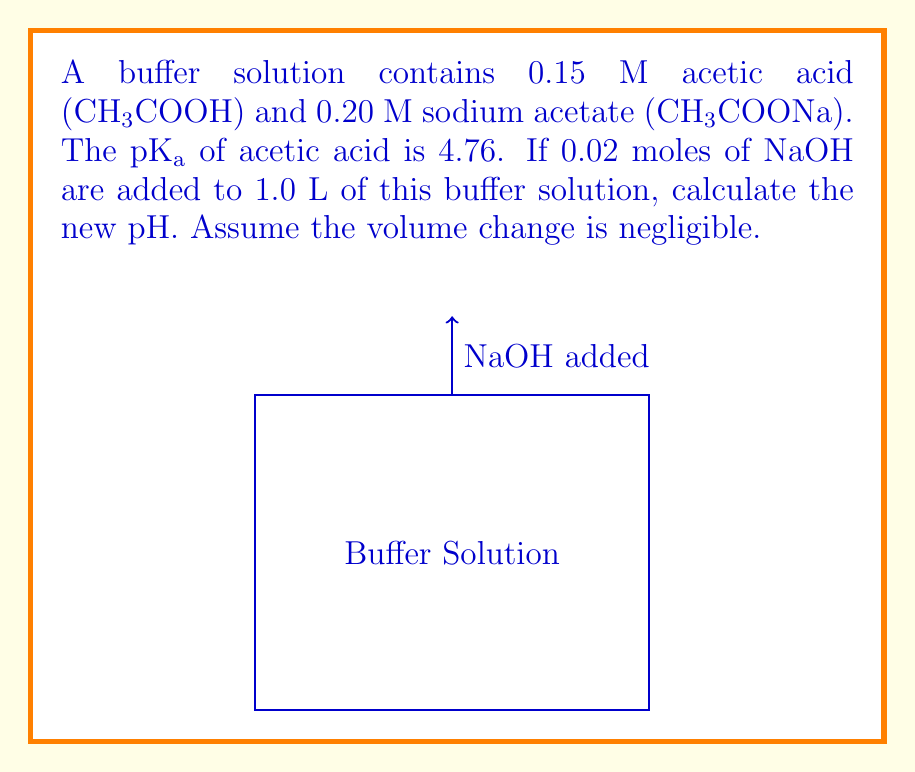Could you help me with this problem? Let's approach this step-by-step:

1) First, let's write the Henderson-Hasselbalch equation:
   $$ pH = pKa + \log\frac{[A^-]}{[HA]} $$

2) Initially, [HA] = 0.15 M and [A⁻] = 0.20 M
   $$ pH_{initial} = 4.76 + \log\frac{0.20}{0.15} = 4.76 + 0.12 = 4.88 $$

3) When NaOH is added, it reacts with HA:
   CH₃COOH + NaOH → CH₃COONa + H₂O

4) 0.02 moles of NaOH will react with 0.02 moles of HA, producing 0.02 moles of A⁻

5) New concentrations:
   [HA]new = 0.15 - 0.02 = 0.13 M
   [A⁻]new = 0.20 + 0.02 = 0.22 M

6) Apply Henderson-Hasselbalch equation with new concentrations:
   $$ pH_{new} = 4.76 + \log\frac{0.22}{0.13} $$

7) Calculate:
   $$ pH_{new} = 4.76 + \log(1.69) = 4.76 + 0.23 = 4.99 $$
Answer: 4.99 